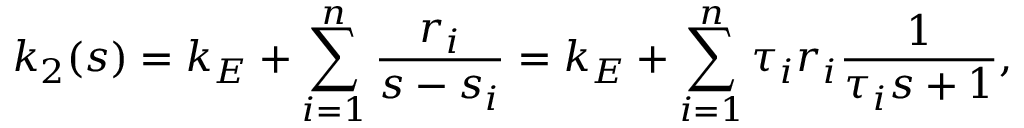<formula> <loc_0><loc_0><loc_500><loc_500>k _ { 2 } ( s ) = k _ { E } + \sum _ { i = 1 } ^ { n } \frac { r _ { i } } { s - s _ { i } } = k _ { E } + \sum _ { i = 1 } ^ { n } \tau _ { i } r _ { i } \frac { 1 } { \tau _ { i } s + 1 } ,</formula> 